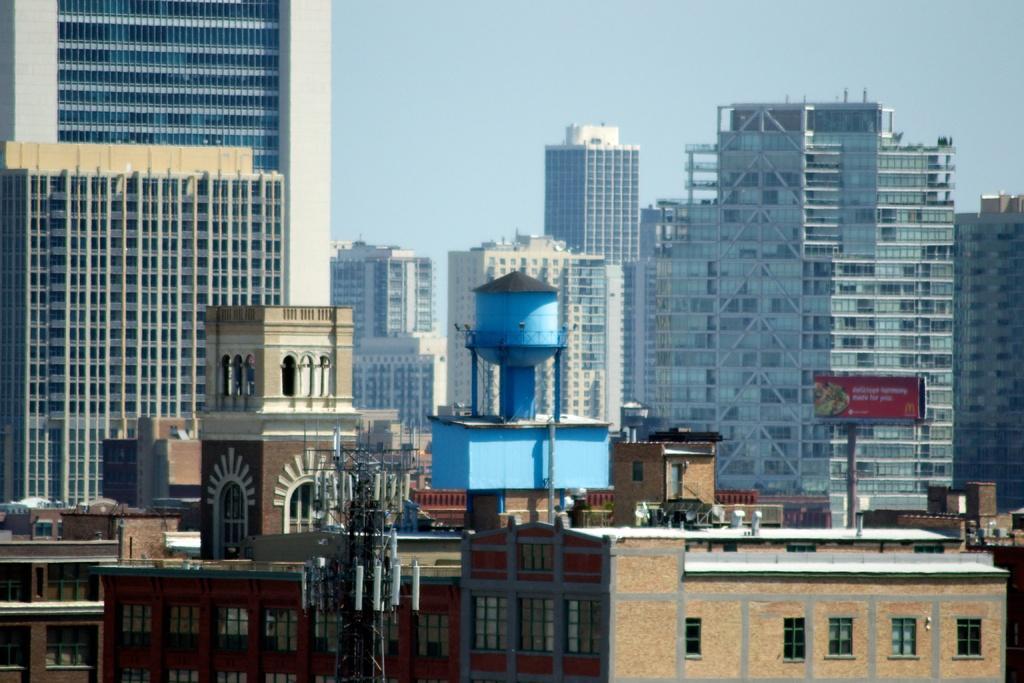Can you describe this image briefly? In this image I can see the tower, many buildings and the sky. To the right I can see the board which is in red color. 